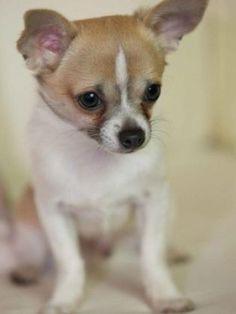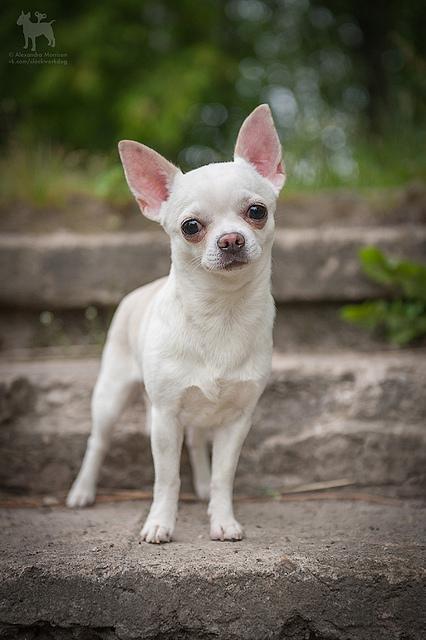The first image is the image on the left, the second image is the image on the right. Given the left and right images, does the statement "A small dog is sitting next to a red object." hold true? Answer yes or no. No. The first image is the image on the left, the second image is the image on the right. Given the left and right images, does the statement "There is a single all white dog in the image on the right." hold true? Answer yes or no. Yes. 